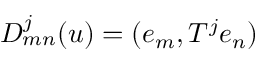<formula> <loc_0><loc_0><loc_500><loc_500>D _ { m n } ^ { j } ( u ) = ( e _ { m } , T ^ { j } e _ { n } )</formula> 